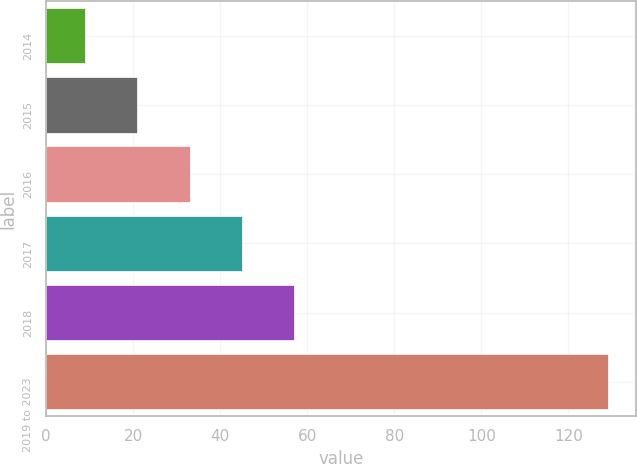Convert chart to OTSL. <chart><loc_0><loc_0><loc_500><loc_500><bar_chart><fcel>2014<fcel>2015<fcel>2016<fcel>2017<fcel>2018<fcel>2019 to 2023<nl><fcel>9<fcel>21<fcel>33<fcel>45<fcel>57<fcel>129<nl></chart> 